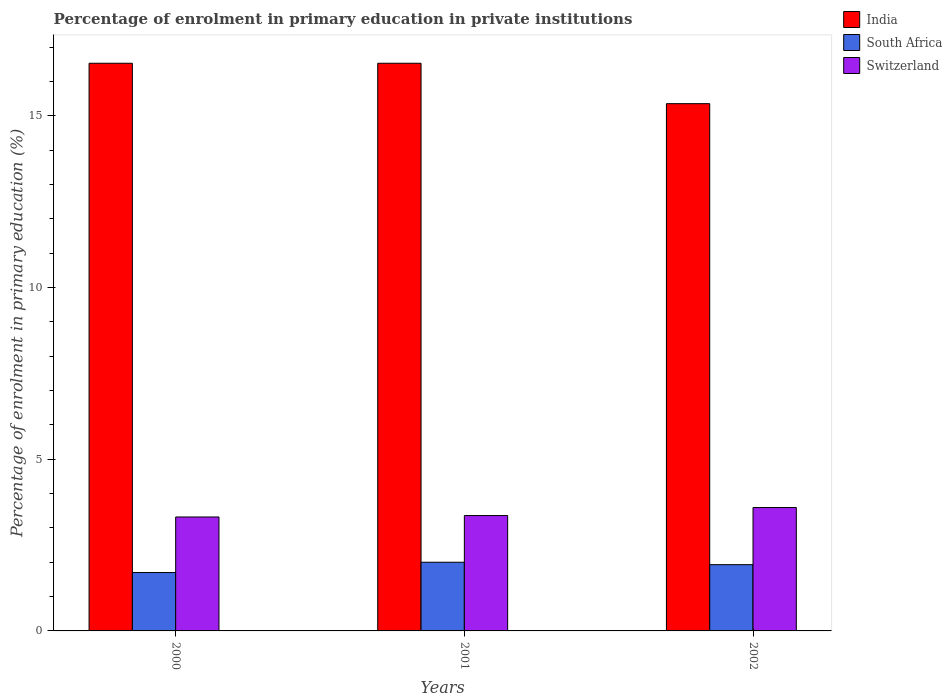Are the number of bars on each tick of the X-axis equal?
Provide a succinct answer. Yes. What is the percentage of enrolment in primary education in South Africa in 2000?
Provide a succinct answer. 1.7. Across all years, what is the maximum percentage of enrolment in primary education in India?
Keep it short and to the point. 16.53. Across all years, what is the minimum percentage of enrolment in primary education in India?
Make the answer very short. 15.35. In which year was the percentage of enrolment in primary education in South Africa maximum?
Provide a short and direct response. 2001. In which year was the percentage of enrolment in primary education in South Africa minimum?
Provide a short and direct response. 2000. What is the total percentage of enrolment in primary education in India in the graph?
Provide a short and direct response. 48.41. What is the difference between the percentage of enrolment in primary education in India in 2000 and that in 2001?
Your response must be concise. 0. What is the difference between the percentage of enrolment in primary education in India in 2000 and the percentage of enrolment in primary education in South Africa in 2002?
Give a very brief answer. 14.6. What is the average percentage of enrolment in primary education in India per year?
Give a very brief answer. 16.14. In the year 2002, what is the difference between the percentage of enrolment in primary education in Switzerland and percentage of enrolment in primary education in India?
Offer a very short reply. -11.76. What is the ratio of the percentage of enrolment in primary education in India in 2000 to that in 2002?
Keep it short and to the point. 1.08. Is the percentage of enrolment in primary education in India in 2000 less than that in 2001?
Provide a short and direct response. No. What is the difference between the highest and the second highest percentage of enrolment in primary education in India?
Your answer should be very brief. 0. What is the difference between the highest and the lowest percentage of enrolment in primary education in South Africa?
Give a very brief answer. 0.3. In how many years, is the percentage of enrolment in primary education in South Africa greater than the average percentage of enrolment in primary education in South Africa taken over all years?
Offer a very short reply. 2. Is the sum of the percentage of enrolment in primary education in South Africa in 2000 and 2002 greater than the maximum percentage of enrolment in primary education in India across all years?
Offer a very short reply. No. What does the 1st bar from the left in 2002 represents?
Give a very brief answer. India. What does the 1st bar from the right in 2001 represents?
Keep it short and to the point. Switzerland. Is it the case that in every year, the sum of the percentage of enrolment in primary education in South Africa and percentage of enrolment in primary education in Switzerland is greater than the percentage of enrolment in primary education in India?
Ensure brevity in your answer.  No. Are all the bars in the graph horizontal?
Offer a terse response. No. What is the difference between two consecutive major ticks on the Y-axis?
Give a very brief answer. 5. Does the graph contain any zero values?
Ensure brevity in your answer.  No. Does the graph contain grids?
Provide a short and direct response. No. What is the title of the graph?
Provide a succinct answer. Percentage of enrolment in primary education in private institutions. Does "Sudan" appear as one of the legend labels in the graph?
Keep it short and to the point. No. What is the label or title of the X-axis?
Offer a very short reply. Years. What is the label or title of the Y-axis?
Offer a terse response. Percentage of enrolment in primary education (%). What is the Percentage of enrolment in primary education (%) in India in 2000?
Your answer should be very brief. 16.53. What is the Percentage of enrolment in primary education (%) of South Africa in 2000?
Make the answer very short. 1.7. What is the Percentage of enrolment in primary education (%) of Switzerland in 2000?
Keep it short and to the point. 3.32. What is the Percentage of enrolment in primary education (%) in India in 2001?
Your answer should be very brief. 16.53. What is the Percentage of enrolment in primary education (%) in South Africa in 2001?
Provide a succinct answer. 2. What is the Percentage of enrolment in primary education (%) of Switzerland in 2001?
Ensure brevity in your answer.  3.36. What is the Percentage of enrolment in primary education (%) of India in 2002?
Keep it short and to the point. 15.35. What is the Percentage of enrolment in primary education (%) of South Africa in 2002?
Your answer should be compact. 1.93. What is the Percentage of enrolment in primary education (%) of Switzerland in 2002?
Your answer should be very brief. 3.59. Across all years, what is the maximum Percentage of enrolment in primary education (%) in India?
Ensure brevity in your answer.  16.53. Across all years, what is the maximum Percentage of enrolment in primary education (%) in South Africa?
Provide a short and direct response. 2. Across all years, what is the maximum Percentage of enrolment in primary education (%) in Switzerland?
Ensure brevity in your answer.  3.59. Across all years, what is the minimum Percentage of enrolment in primary education (%) of India?
Make the answer very short. 15.35. Across all years, what is the minimum Percentage of enrolment in primary education (%) of South Africa?
Your answer should be very brief. 1.7. Across all years, what is the minimum Percentage of enrolment in primary education (%) in Switzerland?
Your answer should be very brief. 3.32. What is the total Percentage of enrolment in primary education (%) in India in the graph?
Your answer should be compact. 48.41. What is the total Percentage of enrolment in primary education (%) in South Africa in the graph?
Ensure brevity in your answer.  5.63. What is the total Percentage of enrolment in primary education (%) of Switzerland in the graph?
Ensure brevity in your answer.  10.27. What is the difference between the Percentage of enrolment in primary education (%) of South Africa in 2000 and that in 2001?
Offer a terse response. -0.3. What is the difference between the Percentage of enrolment in primary education (%) of Switzerland in 2000 and that in 2001?
Make the answer very short. -0.04. What is the difference between the Percentage of enrolment in primary education (%) in India in 2000 and that in 2002?
Make the answer very short. 1.18. What is the difference between the Percentage of enrolment in primary education (%) of South Africa in 2000 and that in 2002?
Ensure brevity in your answer.  -0.23. What is the difference between the Percentage of enrolment in primary education (%) in Switzerland in 2000 and that in 2002?
Offer a very short reply. -0.28. What is the difference between the Percentage of enrolment in primary education (%) of India in 2001 and that in 2002?
Your response must be concise. 1.18. What is the difference between the Percentage of enrolment in primary education (%) of South Africa in 2001 and that in 2002?
Provide a short and direct response. 0.07. What is the difference between the Percentage of enrolment in primary education (%) of Switzerland in 2001 and that in 2002?
Your response must be concise. -0.23. What is the difference between the Percentage of enrolment in primary education (%) of India in 2000 and the Percentage of enrolment in primary education (%) of South Africa in 2001?
Make the answer very short. 14.53. What is the difference between the Percentage of enrolment in primary education (%) of India in 2000 and the Percentage of enrolment in primary education (%) of Switzerland in 2001?
Your answer should be very brief. 13.17. What is the difference between the Percentage of enrolment in primary education (%) in South Africa in 2000 and the Percentage of enrolment in primary education (%) in Switzerland in 2001?
Your response must be concise. -1.66. What is the difference between the Percentage of enrolment in primary education (%) of India in 2000 and the Percentage of enrolment in primary education (%) of South Africa in 2002?
Keep it short and to the point. 14.6. What is the difference between the Percentage of enrolment in primary education (%) in India in 2000 and the Percentage of enrolment in primary education (%) in Switzerland in 2002?
Your answer should be very brief. 12.94. What is the difference between the Percentage of enrolment in primary education (%) of South Africa in 2000 and the Percentage of enrolment in primary education (%) of Switzerland in 2002?
Provide a succinct answer. -1.89. What is the difference between the Percentage of enrolment in primary education (%) in India in 2001 and the Percentage of enrolment in primary education (%) in South Africa in 2002?
Your answer should be very brief. 14.6. What is the difference between the Percentage of enrolment in primary education (%) of India in 2001 and the Percentage of enrolment in primary education (%) of Switzerland in 2002?
Your answer should be very brief. 12.94. What is the difference between the Percentage of enrolment in primary education (%) of South Africa in 2001 and the Percentage of enrolment in primary education (%) of Switzerland in 2002?
Keep it short and to the point. -1.59. What is the average Percentage of enrolment in primary education (%) in India per year?
Ensure brevity in your answer.  16.14. What is the average Percentage of enrolment in primary education (%) of South Africa per year?
Keep it short and to the point. 1.88. What is the average Percentage of enrolment in primary education (%) of Switzerland per year?
Your response must be concise. 3.42. In the year 2000, what is the difference between the Percentage of enrolment in primary education (%) in India and Percentage of enrolment in primary education (%) in South Africa?
Give a very brief answer. 14.83. In the year 2000, what is the difference between the Percentage of enrolment in primary education (%) in India and Percentage of enrolment in primary education (%) in Switzerland?
Provide a short and direct response. 13.21. In the year 2000, what is the difference between the Percentage of enrolment in primary education (%) of South Africa and Percentage of enrolment in primary education (%) of Switzerland?
Make the answer very short. -1.62. In the year 2001, what is the difference between the Percentage of enrolment in primary education (%) in India and Percentage of enrolment in primary education (%) in South Africa?
Your answer should be compact. 14.53. In the year 2001, what is the difference between the Percentage of enrolment in primary education (%) in India and Percentage of enrolment in primary education (%) in Switzerland?
Your response must be concise. 13.17. In the year 2001, what is the difference between the Percentage of enrolment in primary education (%) of South Africa and Percentage of enrolment in primary education (%) of Switzerland?
Give a very brief answer. -1.36. In the year 2002, what is the difference between the Percentage of enrolment in primary education (%) in India and Percentage of enrolment in primary education (%) in South Africa?
Provide a succinct answer. 13.42. In the year 2002, what is the difference between the Percentage of enrolment in primary education (%) in India and Percentage of enrolment in primary education (%) in Switzerland?
Ensure brevity in your answer.  11.76. In the year 2002, what is the difference between the Percentage of enrolment in primary education (%) of South Africa and Percentage of enrolment in primary education (%) of Switzerland?
Your response must be concise. -1.66. What is the ratio of the Percentage of enrolment in primary education (%) of India in 2000 to that in 2001?
Your answer should be compact. 1. What is the ratio of the Percentage of enrolment in primary education (%) of South Africa in 2000 to that in 2001?
Give a very brief answer. 0.85. What is the ratio of the Percentage of enrolment in primary education (%) in India in 2000 to that in 2002?
Provide a succinct answer. 1.08. What is the ratio of the Percentage of enrolment in primary education (%) of South Africa in 2000 to that in 2002?
Your answer should be very brief. 0.88. What is the ratio of the Percentage of enrolment in primary education (%) in Switzerland in 2000 to that in 2002?
Offer a terse response. 0.92. What is the ratio of the Percentage of enrolment in primary education (%) in India in 2001 to that in 2002?
Give a very brief answer. 1.08. What is the ratio of the Percentage of enrolment in primary education (%) of South Africa in 2001 to that in 2002?
Make the answer very short. 1.04. What is the ratio of the Percentage of enrolment in primary education (%) in Switzerland in 2001 to that in 2002?
Provide a short and direct response. 0.93. What is the difference between the highest and the second highest Percentage of enrolment in primary education (%) of South Africa?
Keep it short and to the point. 0.07. What is the difference between the highest and the second highest Percentage of enrolment in primary education (%) in Switzerland?
Provide a short and direct response. 0.23. What is the difference between the highest and the lowest Percentage of enrolment in primary education (%) in India?
Your answer should be compact. 1.18. What is the difference between the highest and the lowest Percentage of enrolment in primary education (%) of Switzerland?
Provide a succinct answer. 0.28. 